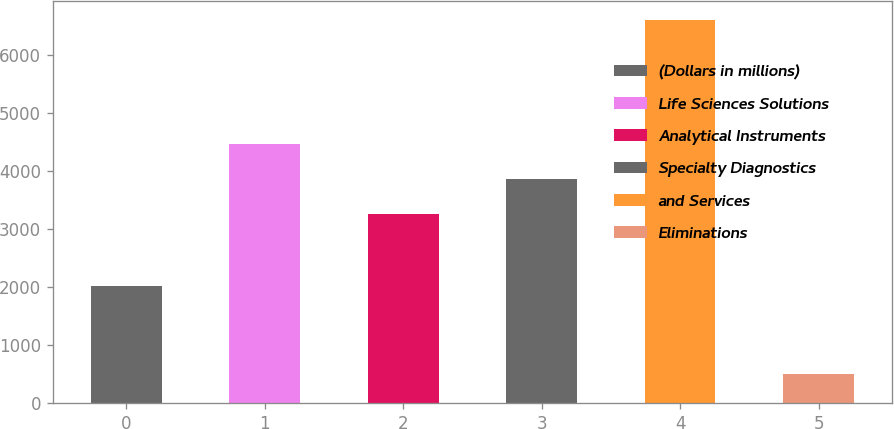Convert chart. <chart><loc_0><loc_0><loc_500><loc_500><bar_chart><fcel>(Dollars in millions)<fcel>Life Sciences Solutions<fcel>Analytical Instruments<fcel>Specialty Diagnostics<fcel>and Services<fcel>Eliminations<nl><fcel>2014<fcel>4471.82<fcel>3252.2<fcel>3862.01<fcel>6601.5<fcel>503.4<nl></chart> 